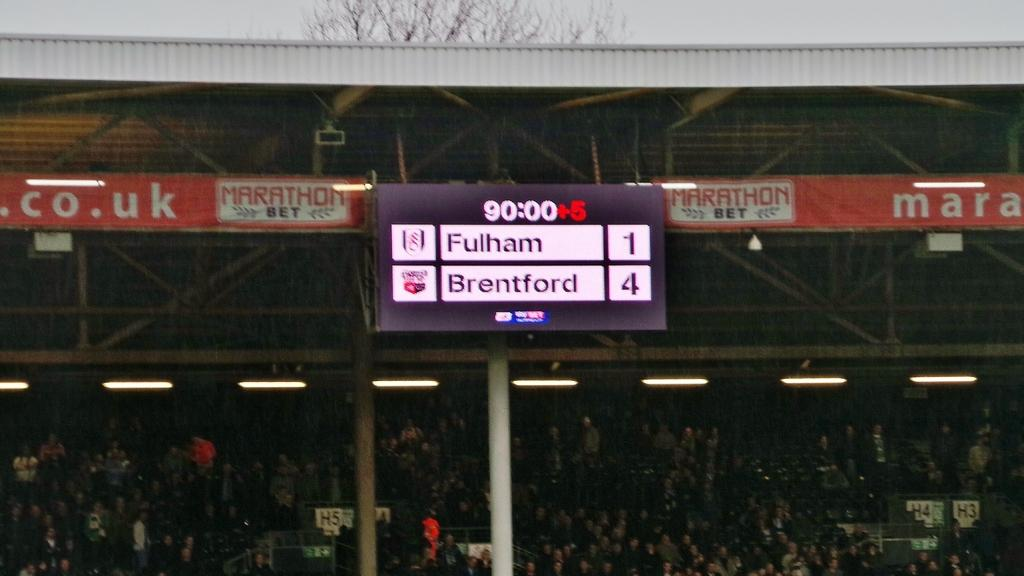Provide a one-sentence caption for the provided image. A scoreboard showing Fulham as having 1 point and Brentford having 4 points. 